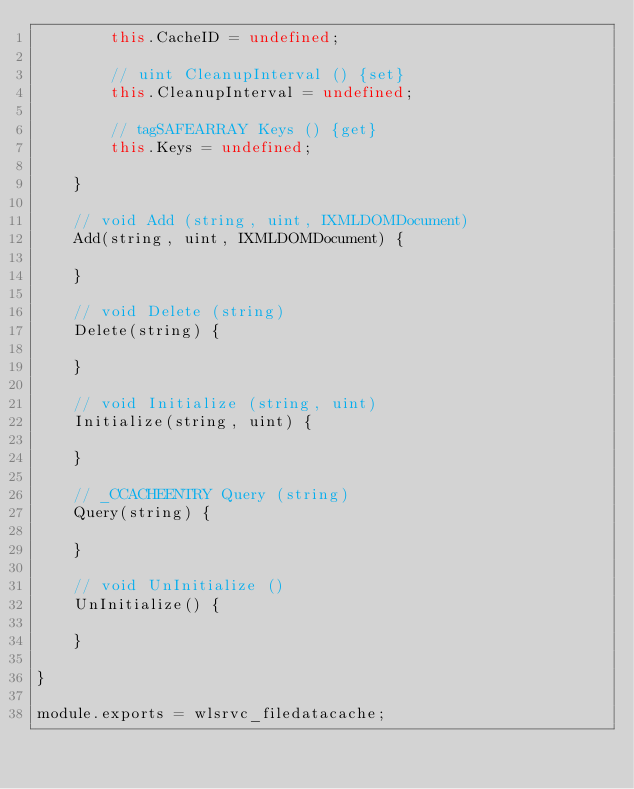Convert code to text. <code><loc_0><loc_0><loc_500><loc_500><_JavaScript_>        this.CacheID = undefined;

        // uint CleanupInterval () {set}
        this.CleanupInterval = undefined;

        // tagSAFEARRAY Keys () {get}
        this.Keys = undefined;

    }

    // void Add (string, uint, IXMLDOMDocument)
    Add(string, uint, IXMLDOMDocument) {

    }

    // void Delete (string)
    Delete(string) {

    }

    // void Initialize (string, uint)
    Initialize(string, uint) {

    }

    // _CCACHEENTRY Query (string)
    Query(string) {

    }

    // void UnInitialize ()
    UnInitialize() {

    }

}

module.exports = wlsrvc_filedatacache;

</code> 